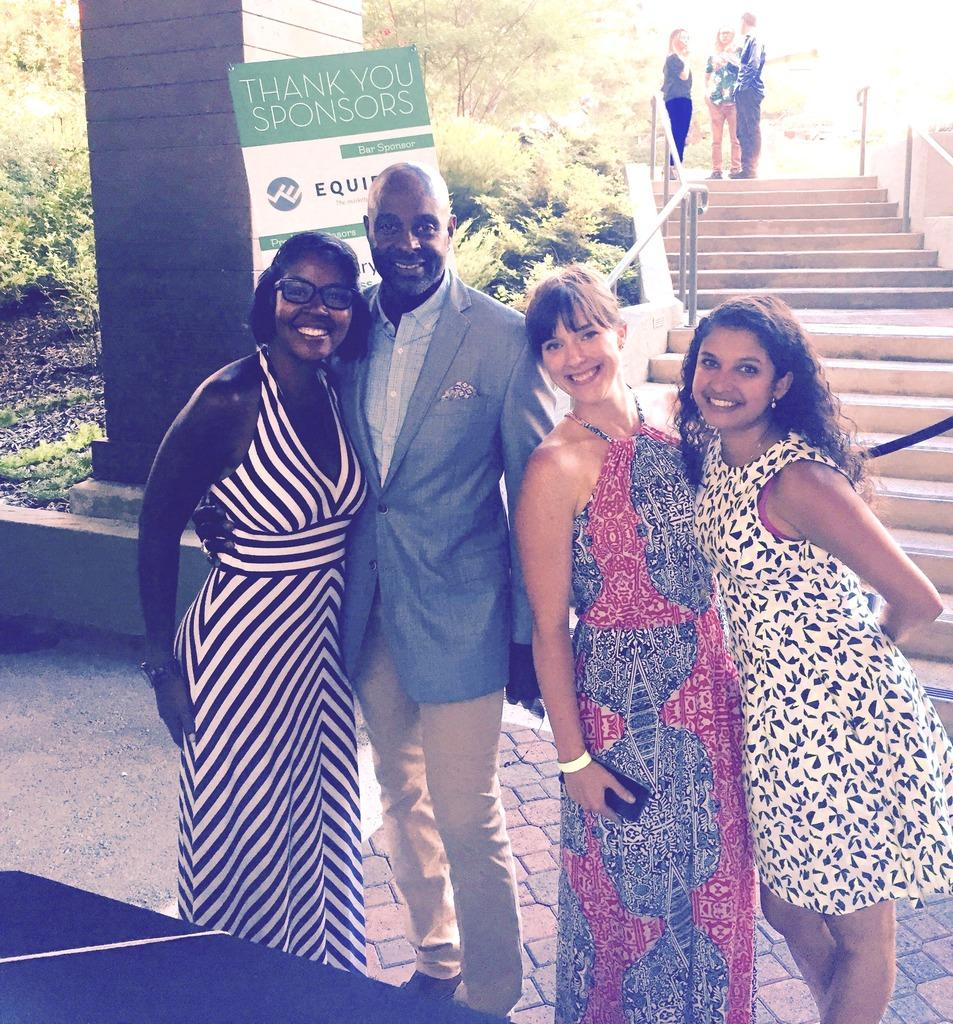Who or what can be seen in the image? There are people in the image. What architectural feature is present in the image? There are stairs in the image. What is located on the left side of the image? There is a board on the left side of the image. What structural element can be seen in the image? There is a pillar in the image. What type of vegetation is visible in the image? There are trees in the image. Where is the drawer located in the image? There is no drawer present in the image. What type of harbor can be seen in the image? There is no harbor present in the image. 